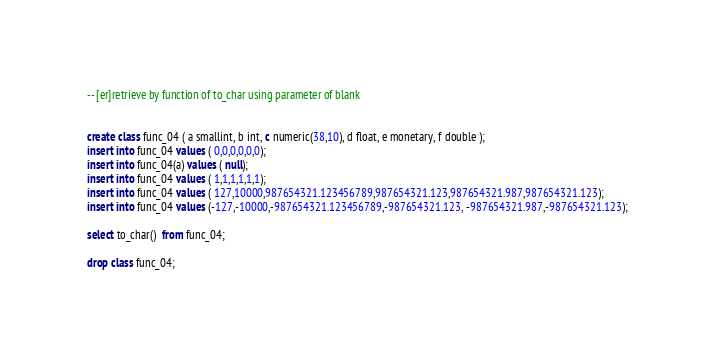<code> <loc_0><loc_0><loc_500><loc_500><_SQL_>-- [er]retrieve by function of to_char using parameter of blank


create class func_04 ( a smallint, b int, c numeric(38,10), d float, e monetary, f double );
insert into func_04 values ( 0,0,0,0,0,0);
insert into func_04(a) values ( null);
insert into func_04 values ( 1,1,1,1,1,1);
insert into func_04 values ( 127,10000,987654321.123456789,987654321.123,987654321.987,987654321.123);
insert into func_04 values (-127,-10000,-987654321.123456789,-987654321.123, -987654321.987,-987654321.123);

select to_char()  from func_04;

drop class func_04;</code> 